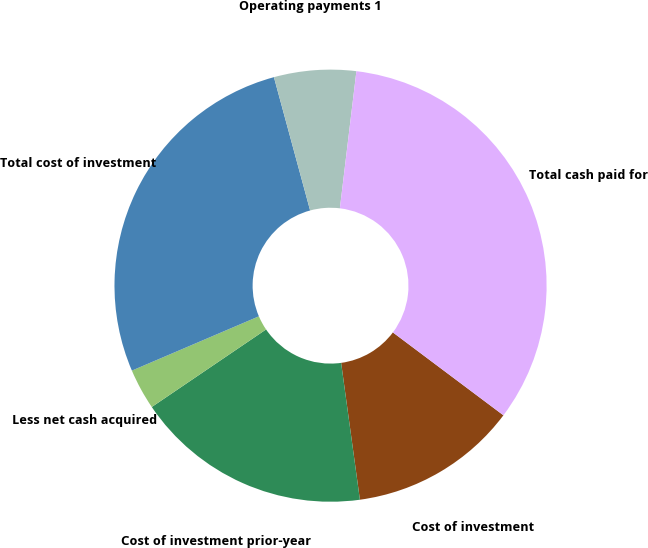<chart> <loc_0><loc_0><loc_500><loc_500><pie_chart><fcel>Cost of investment<fcel>Cost of investment prior-year<fcel>Less net cash acquired<fcel>Total cost of investment<fcel>Operating payments 1<fcel>Total cash paid for<nl><fcel>12.59%<fcel>17.68%<fcel>3.06%<fcel>27.21%<fcel>6.13%<fcel>33.33%<nl></chart> 